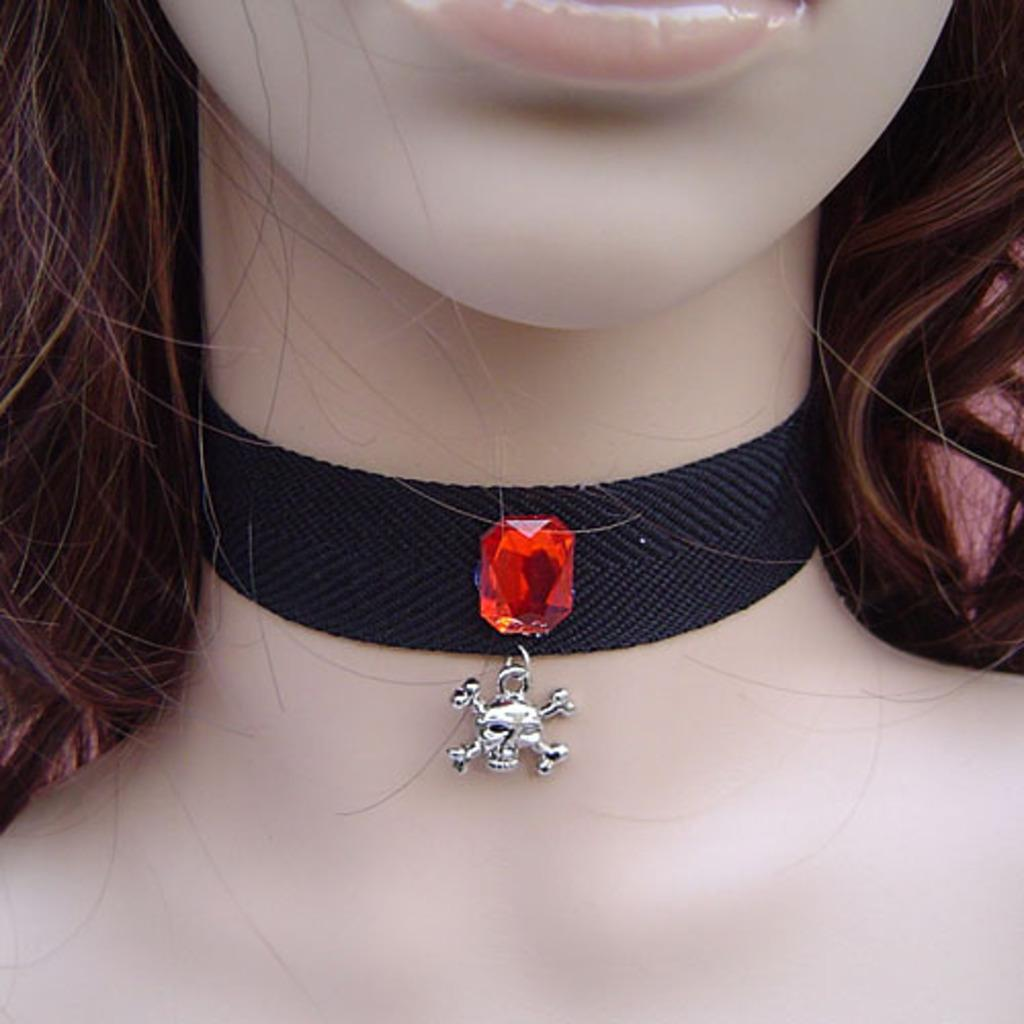Who is the main subject in the image? There is a girl in the image. What is the girl wearing in the image? The girl is wearing a choker. What type of wood is the writer using to create the airplane in the image? There is no wood, writer, or airplane present in the image; it only features a girl wearing a choker. 